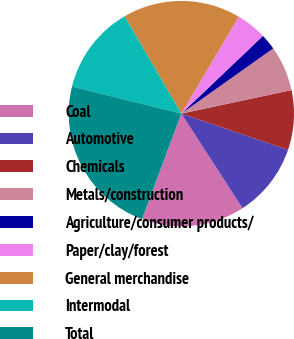<chart> <loc_0><loc_0><loc_500><loc_500><pie_chart><fcel>Coal<fcel>Automotive<fcel>Chemicals<fcel>Metals/construction<fcel>Agriculture/consumer products/<fcel>Paper/clay/forest<fcel>General merchandise<fcel>Intermodal<fcel>Total<nl><fcel>14.82%<fcel>10.65%<fcel>8.56%<fcel>6.47%<fcel>2.29%<fcel>4.38%<fcel>16.91%<fcel>12.74%<fcel>23.18%<nl></chart> 